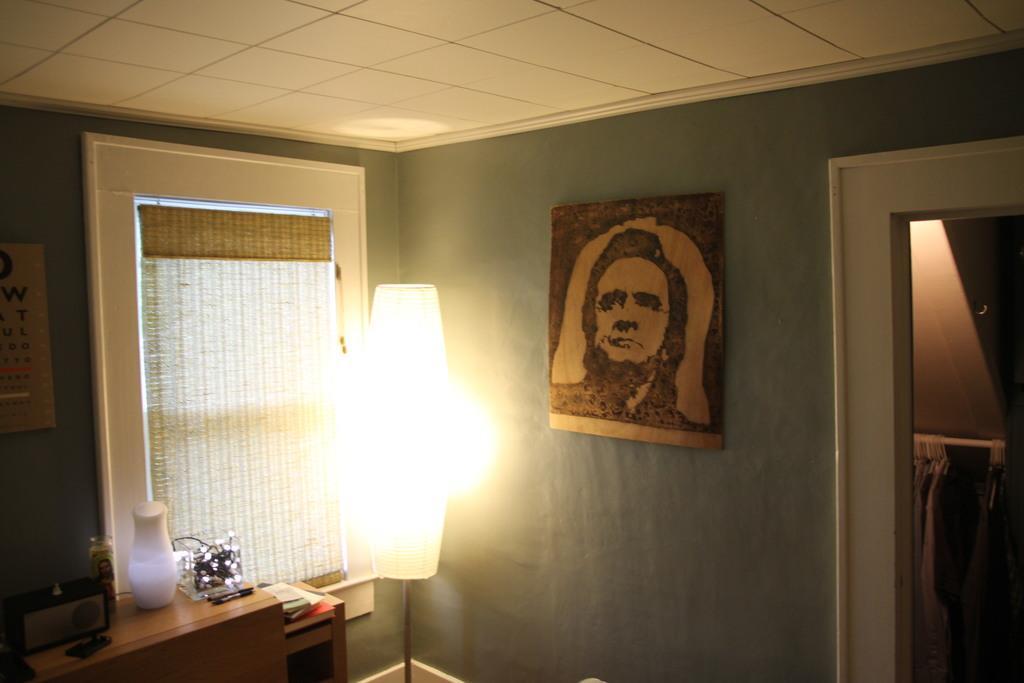Describe this image in one or two sentences. This is the picture of a room. In the foreground there is a lamp. On the right side of the image there is a picture of a man on the wall and there are dresses hanging to the rod. On the left side of the image there are objects and books on the table. There is a calendar on the wall and there is a window blind at the window. 